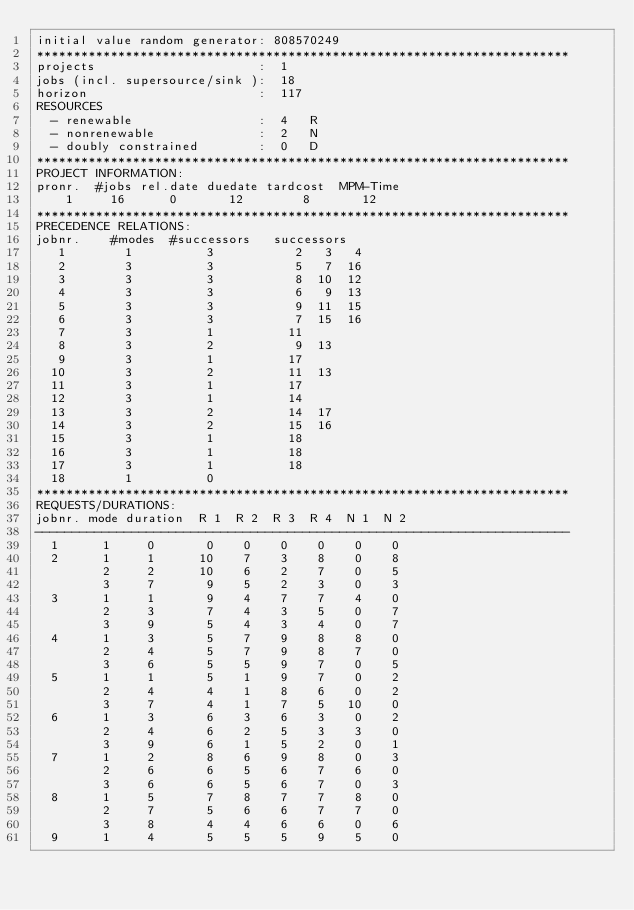Convert code to text. <code><loc_0><loc_0><loc_500><loc_500><_ObjectiveC_>initial value random generator: 808570249
************************************************************************
projects                      :  1
jobs (incl. supersource/sink ):  18
horizon                       :  117
RESOURCES
  - renewable                 :  4   R
  - nonrenewable              :  2   N
  - doubly constrained        :  0   D
************************************************************************
PROJECT INFORMATION:
pronr.  #jobs rel.date duedate tardcost  MPM-Time
    1     16      0       12        8       12
************************************************************************
PRECEDENCE RELATIONS:
jobnr.    #modes  #successors   successors
   1        1          3           2   3   4
   2        3          3           5   7  16
   3        3          3           8  10  12
   4        3          3           6   9  13
   5        3          3           9  11  15
   6        3          3           7  15  16
   7        3          1          11
   8        3          2           9  13
   9        3          1          17
  10        3          2          11  13
  11        3          1          17
  12        3          1          14
  13        3          2          14  17
  14        3          2          15  16
  15        3          1          18
  16        3          1          18
  17        3          1          18
  18        1          0        
************************************************************************
REQUESTS/DURATIONS:
jobnr. mode duration  R 1  R 2  R 3  R 4  N 1  N 2
------------------------------------------------------------------------
  1      1     0       0    0    0    0    0    0
  2      1     1      10    7    3    8    0    8
         2     2      10    6    2    7    0    5
         3     7       9    5    2    3    0    3
  3      1     1       9    4    7    7    4    0
         2     3       7    4    3    5    0    7
         3     9       5    4    3    4    0    7
  4      1     3       5    7    9    8    8    0
         2     4       5    7    9    8    7    0
         3     6       5    5    9    7    0    5
  5      1     1       5    1    9    7    0    2
         2     4       4    1    8    6    0    2
         3     7       4    1    7    5   10    0
  6      1     3       6    3    6    3    0    2
         2     4       6    2    5    3    3    0
         3     9       6    1    5    2    0    1
  7      1     2       8    6    9    8    0    3
         2     6       6    5    6    7    6    0
         3     6       6    5    6    7    0    3
  8      1     5       7    8    7    7    8    0
         2     7       5    6    6    7    7    0
         3     8       4    4    6    6    0    6
  9      1     4       5    5    5    9    5    0</code> 